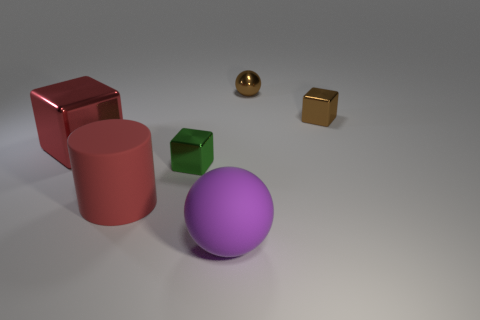What shapes are present in this image? The image features a variety of geometric shapes, including a sphere, a cube, a cylinder, and an object that resembles a rectangular prism. 